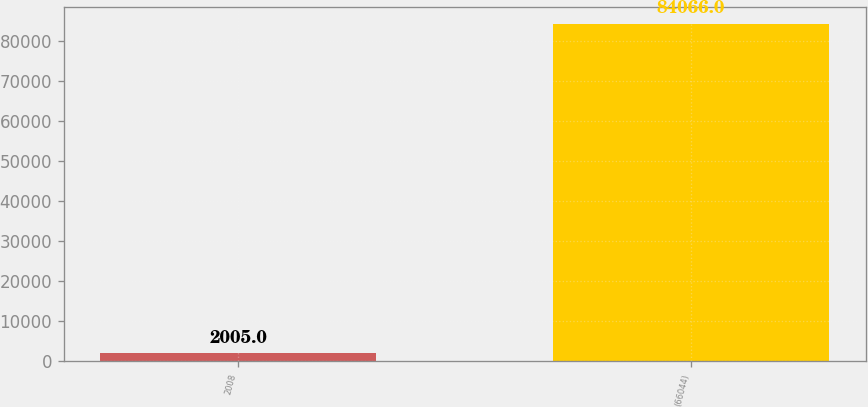<chart> <loc_0><loc_0><loc_500><loc_500><bar_chart><fcel>2008<fcel>(66044)<nl><fcel>2005<fcel>84066<nl></chart> 